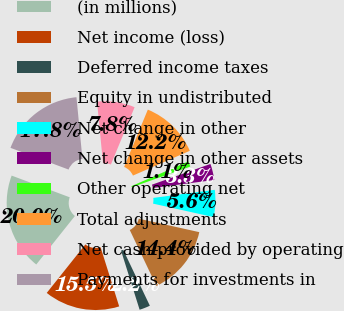Convert chart to OTSL. <chart><loc_0><loc_0><loc_500><loc_500><pie_chart><fcel>(in millions)<fcel>Net income (loss)<fcel>Deferred income taxes<fcel>Equity in undistributed<fcel>Net change in other<fcel>Net change in other assets<fcel>Other operating net<fcel>Total adjustments<fcel>Net cash provided by operating<fcel>Payments for investments in<nl><fcel>19.99%<fcel>15.55%<fcel>2.23%<fcel>14.44%<fcel>5.56%<fcel>3.34%<fcel>1.12%<fcel>12.22%<fcel>7.78%<fcel>17.77%<nl></chart> 